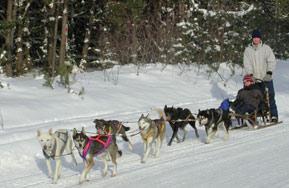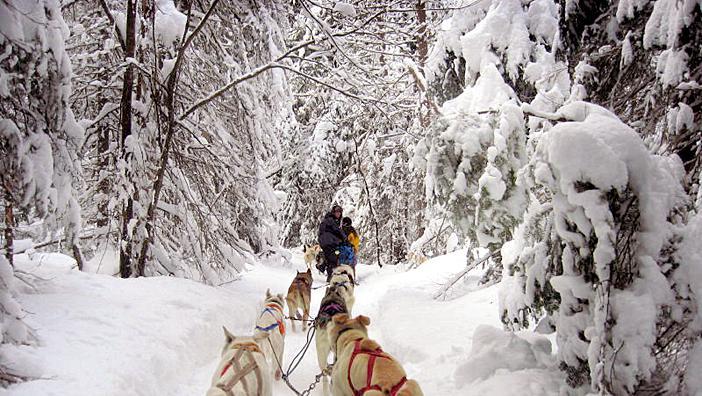The first image is the image on the left, the second image is the image on the right. Analyze the images presented: Is the assertion "There are six dog pulling two people on the sled, over snow." valid? Answer yes or no. No. 